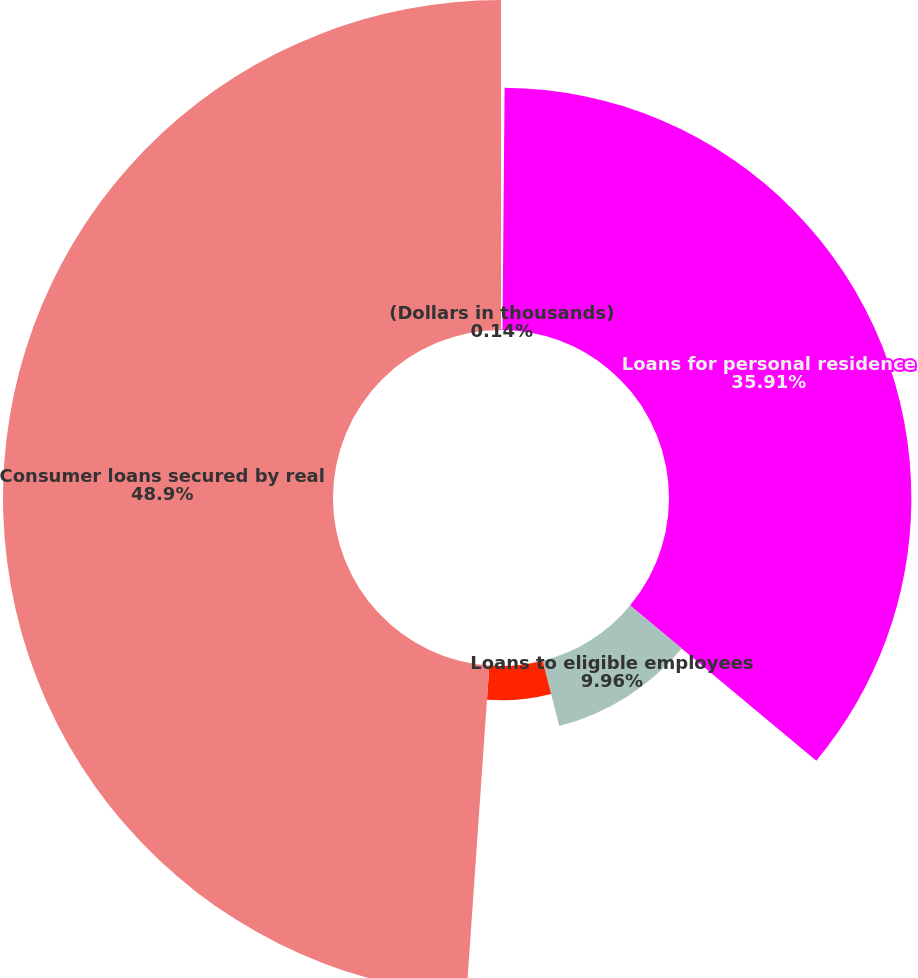Convert chart to OTSL. <chart><loc_0><loc_0><loc_500><loc_500><pie_chart><fcel>(Dollars in thousands)<fcel>Loans for personal residence<fcel>Loans to eligible employees<fcel>Home equity lines of credit<fcel>Consumer loans secured by real<nl><fcel>0.14%<fcel>35.91%<fcel>9.96%<fcel>5.09%<fcel>48.89%<nl></chart> 